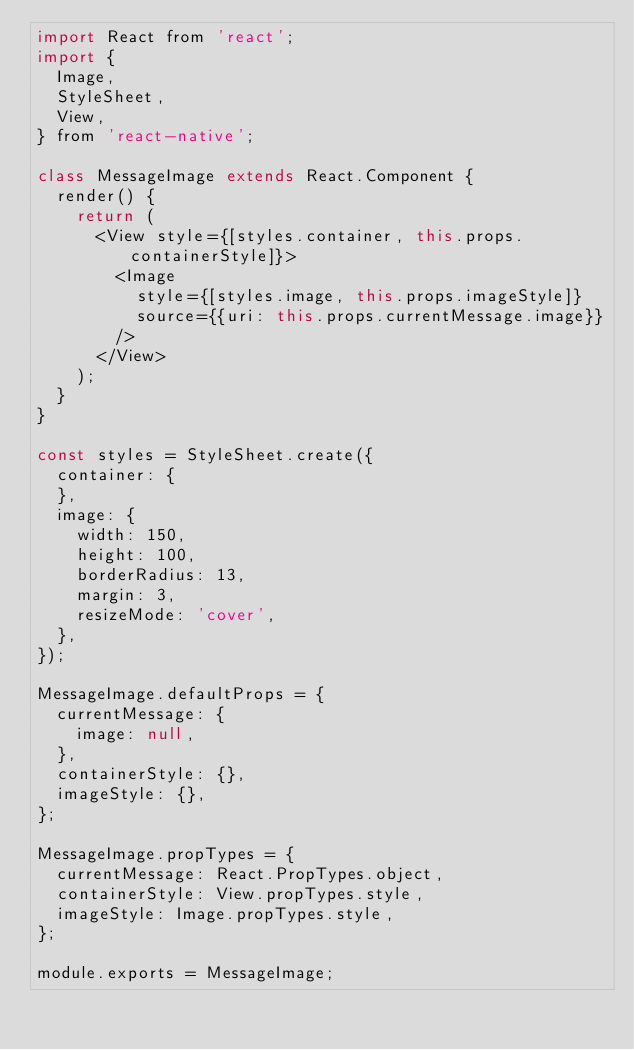Convert code to text. <code><loc_0><loc_0><loc_500><loc_500><_JavaScript_>import React from 'react';
import {
  Image,
  StyleSheet,
  View,
} from 'react-native';

class MessageImage extends React.Component {
  render() {
    return (
      <View style={[styles.container, this.props.containerStyle]}>
        <Image
          style={[styles.image, this.props.imageStyle]}
          source={{uri: this.props.currentMessage.image}}
        />
      </View>
    );
  }
}

const styles = StyleSheet.create({
  container: {
  },
  image: {
    width: 150,
    height: 100,
    borderRadius: 13,
    margin: 3,
    resizeMode: 'cover',
  },
});

MessageImage.defaultProps = {
  currentMessage: {
    image: null,
  },
  containerStyle: {},
  imageStyle: {},
};

MessageImage.propTypes = {
  currentMessage: React.PropTypes.object,
  containerStyle: View.propTypes.style,
  imageStyle: Image.propTypes.style,
};

module.exports = MessageImage;
</code> 